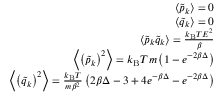<formula> <loc_0><loc_0><loc_500><loc_500>\begin{array} { r } { \left < \tilde { p } _ { k } \right > = 0 } \\ { \left < \tilde { q } _ { k } \right > = 0 } \\ { \left < \tilde { p } _ { k } \tilde { q } _ { k } \right > = \frac { k _ { B } T E ^ { 2 } } { \beta } } \\ { \left < \left ( \tilde { p } _ { k } \right ) ^ { 2 } \right > = k _ { B } T m \left ( 1 - e ^ { - 2 \beta \Delta } \right ) } \\ { \left < \left ( \tilde { q } _ { k } \right ) ^ { 2 } \right > = \frac { k _ { B } T } { m \beta ^ { 2 } } \left ( 2 \beta \Delta - 3 + 4 e ^ { - \beta \Delta } - e ^ { - 2 \beta \Delta } \right ) } \end{array}</formula> 